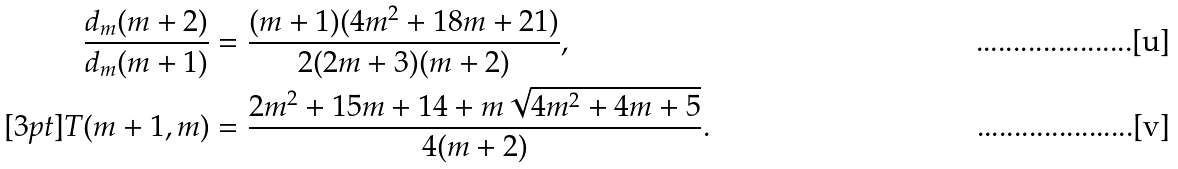<formula> <loc_0><loc_0><loc_500><loc_500>\frac { d _ { m } ( m + 2 ) } { d _ { m } ( m + 1 ) } & = \frac { ( m + 1 ) ( 4 m ^ { 2 } + 1 8 m + 2 1 ) } { 2 ( 2 m + 3 ) ( m + 2 ) } , \\ [ 3 p t ] T ( m + 1 , m ) & = \frac { 2 m ^ { 2 } + 1 5 m + 1 4 + m \sqrt { 4 m ^ { 2 } + 4 m + 5 } } { 4 ( m + 2 ) } .</formula> 